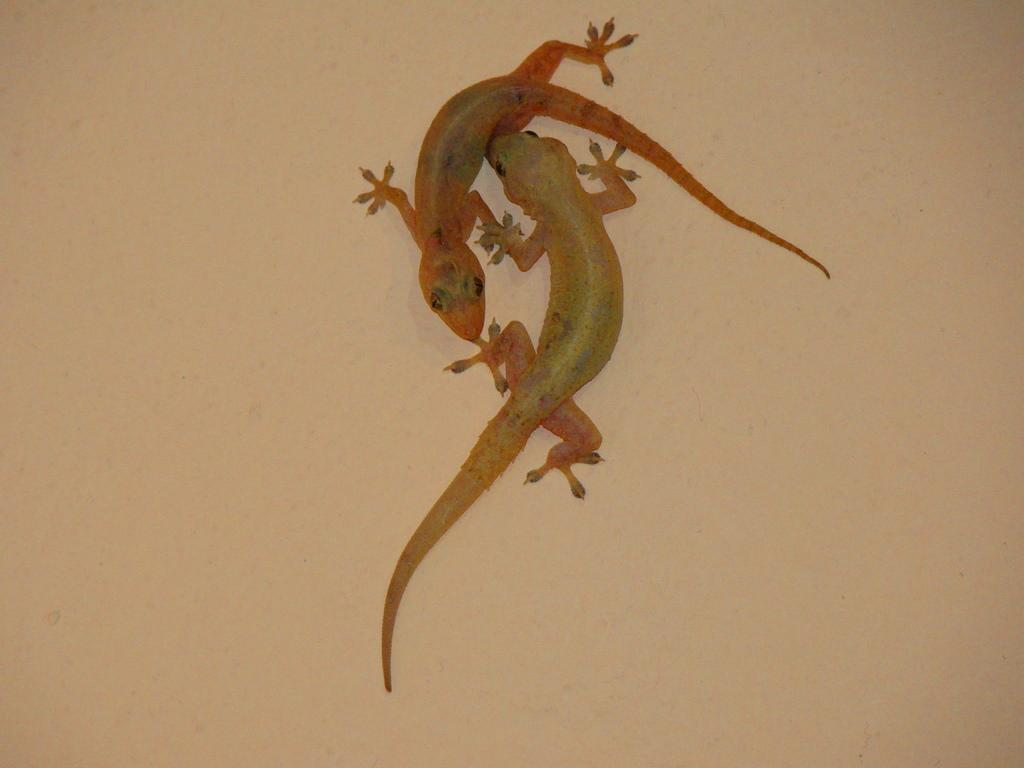What type of animals can be seen on the wall in the image? There are lizards on the wall in the image. What type of key is the bear holding in the image? There is no bear or key present in the image; it only features lizards on the wall. 